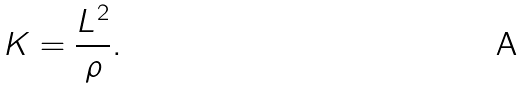Convert formula to latex. <formula><loc_0><loc_0><loc_500><loc_500>K = \frac { L ^ { 2 } } { \rho } .</formula> 